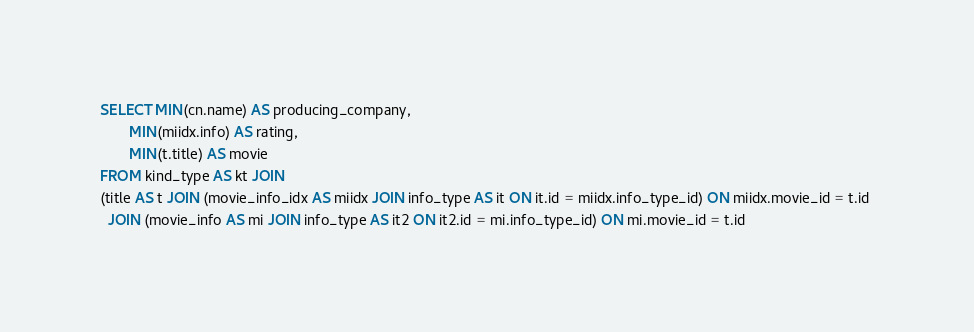<code> <loc_0><loc_0><loc_500><loc_500><_SQL_>SELECT MIN(cn.name) AS producing_company,
       MIN(miidx.info) AS rating,
       MIN(t.title) AS movie
FROM kind_type AS kt JOIN 
(title AS t JOIN (movie_info_idx AS miidx JOIN info_type AS it ON it.id = miidx.info_type_id) ON miidx.movie_id = t.id 
  JOIN (movie_info AS mi JOIN info_type AS it2 ON it2.id = mi.info_type_id) ON mi.movie_id = t.id</code> 